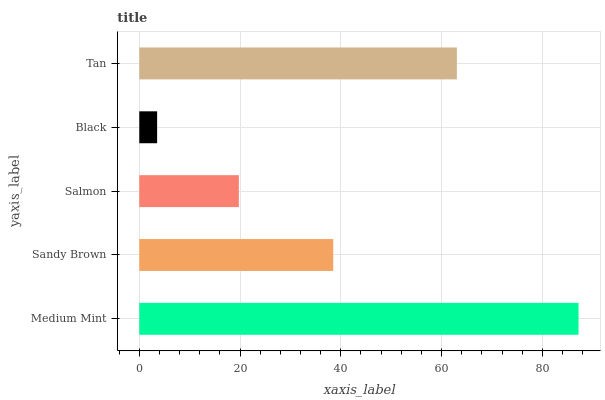Is Black the minimum?
Answer yes or no. Yes. Is Medium Mint the maximum?
Answer yes or no. Yes. Is Sandy Brown the minimum?
Answer yes or no. No. Is Sandy Brown the maximum?
Answer yes or no. No. Is Medium Mint greater than Sandy Brown?
Answer yes or no. Yes. Is Sandy Brown less than Medium Mint?
Answer yes or no. Yes. Is Sandy Brown greater than Medium Mint?
Answer yes or no. No. Is Medium Mint less than Sandy Brown?
Answer yes or no. No. Is Sandy Brown the high median?
Answer yes or no. Yes. Is Sandy Brown the low median?
Answer yes or no. Yes. Is Medium Mint the high median?
Answer yes or no. No. Is Salmon the low median?
Answer yes or no. No. 